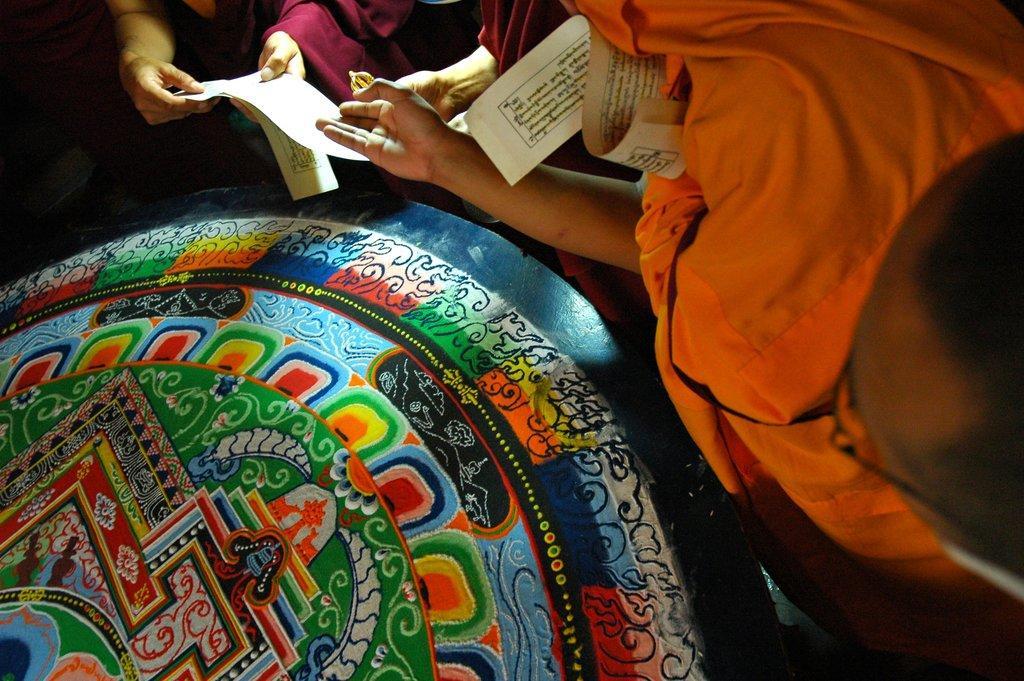How would you summarize this image in a sentence or two? In the bottom left corner of the image we can see a table. At the top of the image few people are standing and holding some papers. 